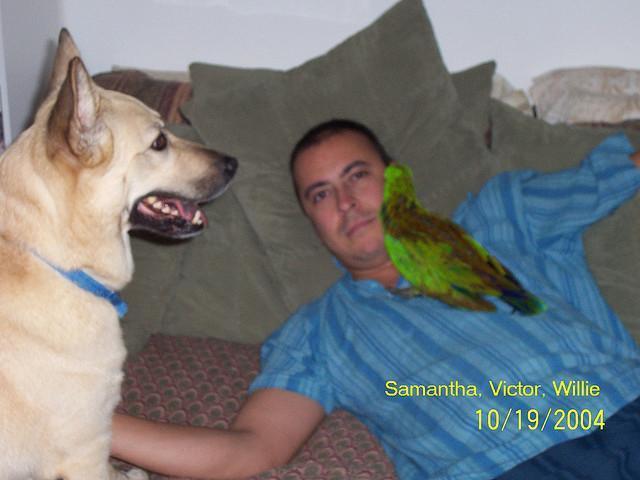Is "The bird is at the back of the person." an appropriate description for the image?
Answer yes or no. No. 